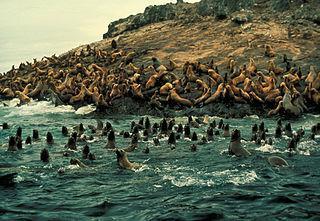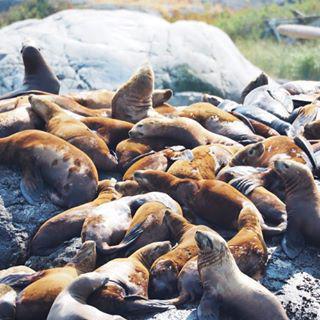The first image is the image on the left, the second image is the image on the right. Evaluate the accuracy of this statement regarding the images: "The corners of floating platforms piled with reclining seals are visible in just one image.". Is it true? Answer yes or no. No. The first image is the image on the left, the second image is the image on the right. Considering the images on both sides, is "In at least one of the images, there are vertical wooden poles sticking up from the docks." valid? Answer yes or no. No. 